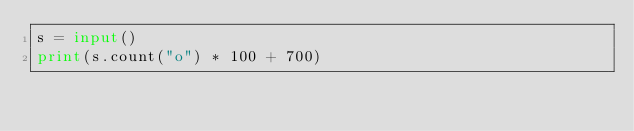Convert code to text. <code><loc_0><loc_0><loc_500><loc_500><_Python_>s = input()
print(s.count("o") * 100 + 700)</code> 